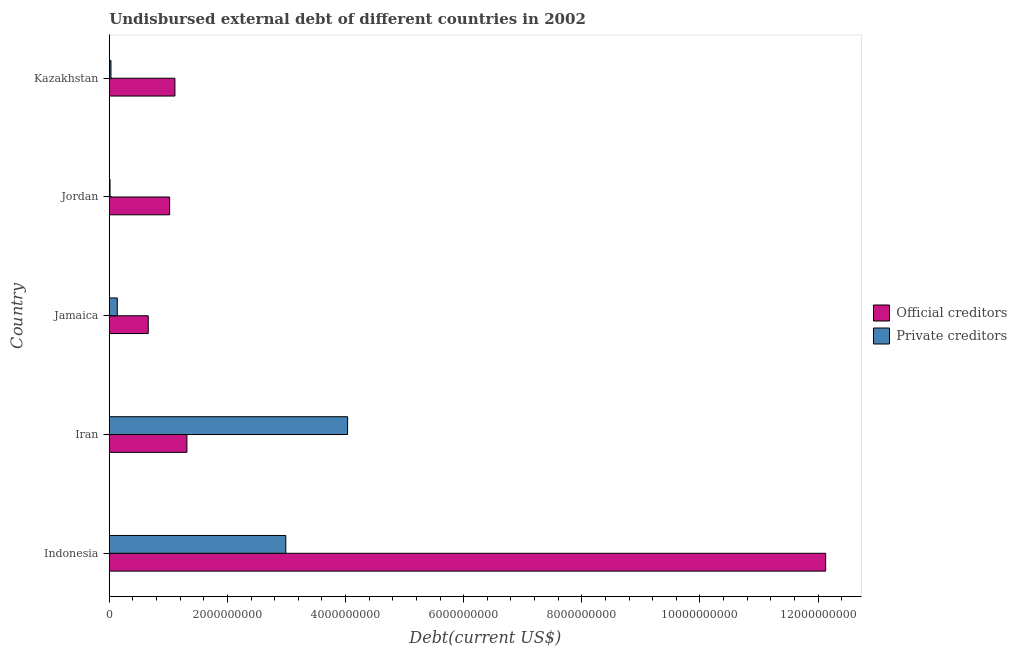How many different coloured bars are there?
Your answer should be compact. 2. How many groups of bars are there?
Offer a terse response. 5. Are the number of bars per tick equal to the number of legend labels?
Your answer should be very brief. Yes. How many bars are there on the 2nd tick from the top?
Offer a very short reply. 2. How many bars are there on the 3rd tick from the bottom?
Your answer should be very brief. 2. What is the undisbursed external debt of official creditors in Kazakhstan?
Your answer should be compact. 1.11e+09. Across all countries, what is the maximum undisbursed external debt of official creditors?
Provide a succinct answer. 1.21e+1. Across all countries, what is the minimum undisbursed external debt of official creditors?
Offer a very short reply. 6.60e+08. In which country was the undisbursed external debt of private creditors maximum?
Provide a succinct answer. Iran. In which country was the undisbursed external debt of official creditors minimum?
Provide a succinct answer. Jamaica. What is the total undisbursed external debt of private creditors in the graph?
Offer a very short reply. 7.20e+09. What is the difference between the undisbursed external debt of private creditors in Iran and that in Jordan?
Keep it short and to the point. 4.02e+09. What is the difference between the undisbursed external debt of official creditors in Iran and the undisbursed external debt of private creditors in Jordan?
Offer a terse response. 1.30e+09. What is the average undisbursed external debt of official creditors per country?
Offer a terse response. 3.25e+09. What is the difference between the undisbursed external debt of official creditors and undisbursed external debt of private creditors in Iran?
Your answer should be compact. -2.72e+09. What is the ratio of the undisbursed external debt of private creditors in Jamaica to that in Jordan?
Offer a very short reply. 10.45. Is the difference between the undisbursed external debt of private creditors in Iran and Jordan greater than the difference between the undisbursed external debt of official creditors in Iran and Jordan?
Your answer should be compact. Yes. What is the difference between the highest and the second highest undisbursed external debt of official creditors?
Your answer should be very brief. 1.08e+1. What is the difference between the highest and the lowest undisbursed external debt of private creditors?
Provide a short and direct response. 4.02e+09. Is the sum of the undisbursed external debt of private creditors in Jamaica and Jordan greater than the maximum undisbursed external debt of official creditors across all countries?
Keep it short and to the point. No. What does the 2nd bar from the top in Iran represents?
Ensure brevity in your answer.  Official creditors. What does the 2nd bar from the bottom in Jamaica represents?
Your response must be concise. Private creditors. How many bars are there?
Provide a short and direct response. 10. What is the difference between two consecutive major ticks on the X-axis?
Make the answer very short. 2.00e+09. Are the values on the major ticks of X-axis written in scientific E-notation?
Give a very brief answer. No. Does the graph contain any zero values?
Your response must be concise. No. Where does the legend appear in the graph?
Your response must be concise. Center right. How are the legend labels stacked?
Provide a succinct answer. Vertical. What is the title of the graph?
Provide a short and direct response. Undisbursed external debt of different countries in 2002. What is the label or title of the X-axis?
Provide a succinct answer. Debt(current US$). What is the label or title of the Y-axis?
Give a very brief answer. Country. What is the Debt(current US$) in Official creditors in Indonesia?
Your answer should be compact. 1.21e+1. What is the Debt(current US$) in Private creditors in Indonesia?
Your answer should be very brief. 2.99e+09. What is the Debt(current US$) of Official creditors in Iran?
Your answer should be compact. 1.31e+09. What is the Debt(current US$) of Private creditors in Iran?
Ensure brevity in your answer.  4.04e+09. What is the Debt(current US$) of Official creditors in Jamaica?
Offer a terse response. 6.60e+08. What is the Debt(current US$) of Private creditors in Jamaica?
Offer a terse response. 1.36e+08. What is the Debt(current US$) in Official creditors in Jordan?
Your answer should be very brief. 1.02e+09. What is the Debt(current US$) of Private creditors in Jordan?
Give a very brief answer. 1.30e+07. What is the Debt(current US$) of Official creditors in Kazakhstan?
Make the answer very short. 1.11e+09. What is the Debt(current US$) in Private creditors in Kazakhstan?
Offer a terse response. 2.88e+07. Across all countries, what is the maximum Debt(current US$) in Official creditors?
Your answer should be very brief. 1.21e+1. Across all countries, what is the maximum Debt(current US$) of Private creditors?
Your answer should be compact. 4.04e+09. Across all countries, what is the minimum Debt(current US$) in Official creditors?
Your response must be concise. 6.60e+08. Across all countries, what is the minimum Debt(current US$) of Private creditors?
Keep it short and to the point. 1.30e+07. What is the total Debt(current US$) of Official creditors in the graph?
Keep it short and to the point. 1.62e+1. What is the total Debt(current US$) of Private creditors in the graph?
Your answer should be very brief. 7.20e+09. What is the difference between the Debt(current US$) of Official creditors in Indonesia and that in Iran?
Give a very brief answer. 1.08e+1. What is the difference between the Debt(current US$) in Private creditors in Indonesia and that in Iran?
Offer a terse response. -1.05e+09. What is the difference between the Debt(current US$) of Official creditors in Indonesia and that in Jamaica?
Provide a succinct answer. 1.15e+1. What is the difference between the Debt(current US$) in Private creditors in Indonesia and that in Jamaica?
Your answer should be compact. 2.85e+09. What is the difference between the Debt(current US$) in Official creditors in Indonesia and that in Jordan?
Keep it short and to the point. 1.11e+1. What is the difference between the Debt(current US$) of Private creditors in Indonesia and that in Jordan?
Offer a very short reply. 2.98e+09. What is the difference between the Debt(current US$) of Official creditors in Indonesia and that in Kazakhstan?
Give a very brief answer. 1.10e+1. What is the difference between the Debt(current US$) of Private creditors in Indonesia and that in Kazakhstan?
Ensure brevity in your answer.  2.96e+09. What is the difference between the Debt(current US$) in Official creditors in Iran and that in Jamaica?
Your answer should be very brief. 6.54e+08. What is the difference between the Debt(current US$) in Private creditors in Iran and that in Jamaica?
Provide a short and direct response. 3.90e+09. What is the difference between the Debt(current US$) of Official creditors in Iran and that in Jordan?
Your answer should be very brief. 2.92e+08. What is the difference between the Debt(current US$) of Private creditors in Iran and that in Jordan?
Your answer should be very brief. 4.02e+09. What is the difference between the Debt(current US$) in Official creditors in Iran and that in Kazakhstan?
Make the answer very short. 2.03e+08. What is the difference between the Debt(current US$) in Private creditors in Iran and that in Kazakhstan?
Provide a short and direct response. 4.01e+09. What is the difference between the Debt(current US$) of Official creditors in Jamaica and that in Jordan?
Provide a succinct answer. -3.62e+08. What is the difference between the Debt(current US$) of Private creditors in Jamaica and that in Jordan?
Your response must be concise. 1.23e+08. What is the difference between the Debt(current US$) of Official creditors in Jamaica and that in Kazakhstan?
Ensure brevity in your answer.  -4.52e+08. What is the difference between the Debt(current US$) in Private creditors in Jamaica and that in Kazakhstan?
Make the answer very short. 1.07e+08. What is the difference between the Debt(current US$) in Official creditors in Jordan and that in Kazakhstan?
Offer a very short reply. -8.94e+07. What is the difference between the Debt(current US$) of Private creditors in Jordan and that in Kazakhstan?
Offer a very short reply. -1.58e+07. What is the difference between the Debt(current US$) of Official creditors in Indonesia and the Debt(current US$) of Private creditors in Iran?
Give a very brief answer. 8.09e+09. What is the difference between the Debt(current US$) of Official creditors in Indonesia and the Debt(current US$) of Private creditors in Jamaica?
Offer a very short reply. 1.20e+1. What is the difference between the Debt(current US$) of Official creditors in Indonesia and the Debt(current US$) of Private creditors in Jordan?
Ensure brevity in your answer.  1.21e+1. What is the difference between the Debt(current US$) of Official creditors in Indonesia and the Debt(current US$) of Private creditors in Kazakhstan?
Keep it short and to the point. 1.21e+1. What is the difference between the Debt(current US$) of Official creditors in Iran and the Debt(current US$) of Private creditors in Jamaica?
Provide a short and direct response. 1.18e+09. What is the difference between the Debt(current US$) of Official creditors in Iran and the Debt(current US$) of Private creditors in Jordan?
Make the answer very short. 1.30e+09. What is the difference between the Debt(current US$) of Official creditors in Iran and the Debt(current US$) of Private creditors in Kazakhstan?
Provide a short and direct response. 1.29e+09. What is the difference between the Debt(current US$) of Official creditors in Jamaica and the Debt(current US$) of Private creditors in Jordan?
Make the answer very short. 6.47e+08. What is the difference between the Debt(current US$) of Official creditors in Jamaica and the Debt(current US$) of Private creditors in Kazakhstan?
Provide a short and direct response. 6.31e+08. What is the difference between the Debt(current US$) of Official creditors in Jordan and the Debt(current US$) of Private creditors in Kazakhstan?
Your answer should be very brief. 9.93e+08. What is the average Debt(current US$) in Official creditors per country?
Make the answer very short. 3.25e+09. What is the average Debt(current US$) in Private creditors per country?
Your answer should be compact. 1.44e+09. What is the difference between the Debt(current US$) in Official creditors and Debt(current US$) in Private creditors in Indonesia?
Give a very brief answer. 9.14e+09. What is the difference between the Debt(current US$) in Official creditors and Debt(current US$) in Private creditors in Iran?
Your answer should be compact. -2.72e+09. What is the difference between the Debt(current US$) of Official creditors and Debt(current US$) of Private creditors in Jamaica?
Provide a short and direct response. 5.24e+08. What is the difference between the Debt(current US$) of Official creditors and Debt(current US$) of Private creditors in Jordan?
Ensure brevity in your answer.  1.01e+09. What is the difference between the Debt(current US$) of Official creditors and Debt(current US$) of Private creditors in Kazakhstan?
Make the answer very short. 1.08e+09. What is the ratio of the Debt(current US$) of Official creditors in Indonesia to that in Iran?
Ensure brevity in your answer.  9.23. What is the ratio of the Debt(current US$) in Private creditors in Indonesia to that in Iran?
Give a very brief answer. 0.74. What is the ratio of the Debt(current US$) in Official creditors in Indonesia to that in Jamaica?
Your answer should be very brief. 18.38. What is the ratio of the Debt(current US$) of Private creditors in Indonesia to that in Jamaica?
Offer a very short reply. 22.03. What is the ratio of the Debt(current US$) in Official creditors in Indonesia to that in Jordan?
Make the answer very short. 11.87. What is the ratio of the Debt(current US$) in Private creditors in Indonesia to that in Jordan?
Keep it short and to the point. 230.28. What is the ratio of the Debt(current US$) of Official creditors in Indonesia to that in Kazakhstan?
Ensure brevity in your answer.  10.91. What is the ratio of the Debt(current US$) in Private creditors in Indonesia to that in Kazakhstan?
Your answer should be compact. 103.87. What is the ratio of the Debt(current US$) in Official creditors in Iran to that in Jamaica?
Your response must be concise. 1.99. What is the ratio of the Debt(current US$) of Private creditors in Iran to that in Jamaica?
Ensure brevity in your answer.  29.74. What is the ratio of the Debt(current US$) of Official creditors in Iran to that in Jordan?
Offer a terse response. 1.29. What is the ratio of the Debt(current US$) in Private creditors in Iran to that in Jordan?
Make the answer very short. 310.86. What is the ratio of the Debt(current US$) of Official creditors in Iran to that in Kazakhstan?
Offer a very short reply. 1.18. What is the ratio of the Debt(current US$) in Private creditors in Iran to that in Kazakhstan?
Make the answer very short. 140.22. What is the ratio of the Debt(current US$) of Official creditors in Jamaica to that in Jordan?
Provide a succinct answer. 0.65. What is the ratio of the Debt(current US$) of Private creditors in Jamaica to that in Jordan?
Provide a succinct answer. 10.45. What is the ratio of the Debt(current US$) of Official creditors in Jamaica to that in Kazakhstan?
Provide a short and direct response. 0.59. What is the ratio of the Debt(current US$) of Private creditors in Jamaica to that in Kazakhstan?
Offer a terse response. 4.71. What is the ratio of the Debt(current US$) of Official creditors in Jordan to that in Kazakhstan?
Provide a succinct answer. 0.92. What is the ratio of the Debt(current US$) in Private creditors in Jordan to that in Kazakhstan?
Your answer should be very brief. 0.45. What is the difference between the highest and the second highest Debt(current US$) in Official creditors?
Keep it short and to the point. 1.08e+1. What is the difference between the highest and the second highest Debt(current US$) of Private creditors?
Your answer should be very brief. 1.05e+09. What is the difference between the highest and the lowest Debt(current US$) in Official creditors?
Provide a short and direct response. 1.15e+1. What is the difference between the highest and the lowest Debt(current US$) in Private creditors?
Keep it short and to the point. 4.02e+09. 